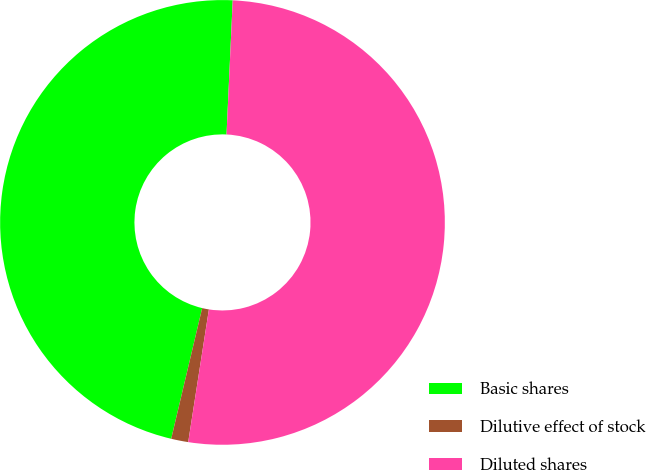Convert chart. <chart><loc_0><loc_0><loc_500><loc_500><pie_chart><fcel>Basic shares<fcel>Dilutive effect of stock<fcel>Diluted shares<nl><fcel>47.03%<fcel>1.24%<fcel>51.73%<nl></chart> 